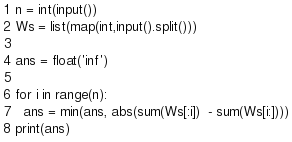<code> <loc_0><loc_0><loc_500><loc_500><_Python_>n = int(input())
Ws = list(map(int,input().split()))

ans = float('inf')

for i in range(n):
  ans = min(ans, abs(sum(Ws[:i])  - sum(Ws[i:])))
print(ans)

</code> 